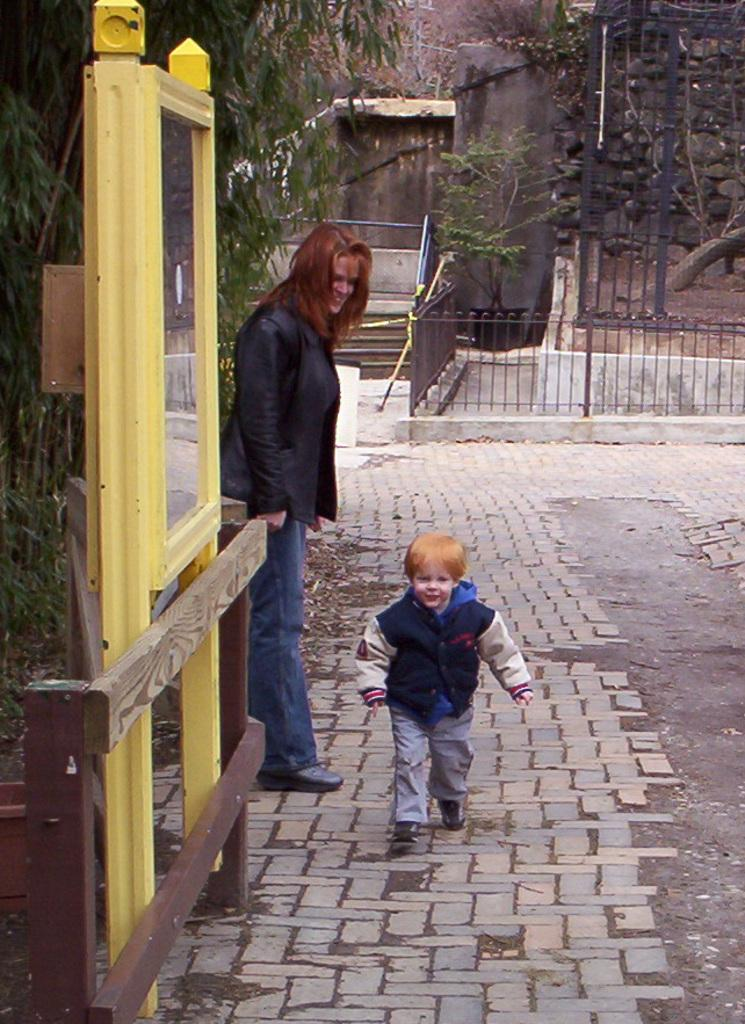Who can be seen in the middle of the image? There is a woman and a child in the middle of the image. What object is located on the left side of the image? There is a mirror on the left side of the image. What can be seen in the background of the image? There is railing and a wall in the background of the image. How many teeth can be seen in the mirror in the image? There are no teeth visible in the mirror in the image. What type of chickens can be seen in the background of the image? There are no chickens present in the image; it features a woman, a child, a mirror, railing, and a wall. 